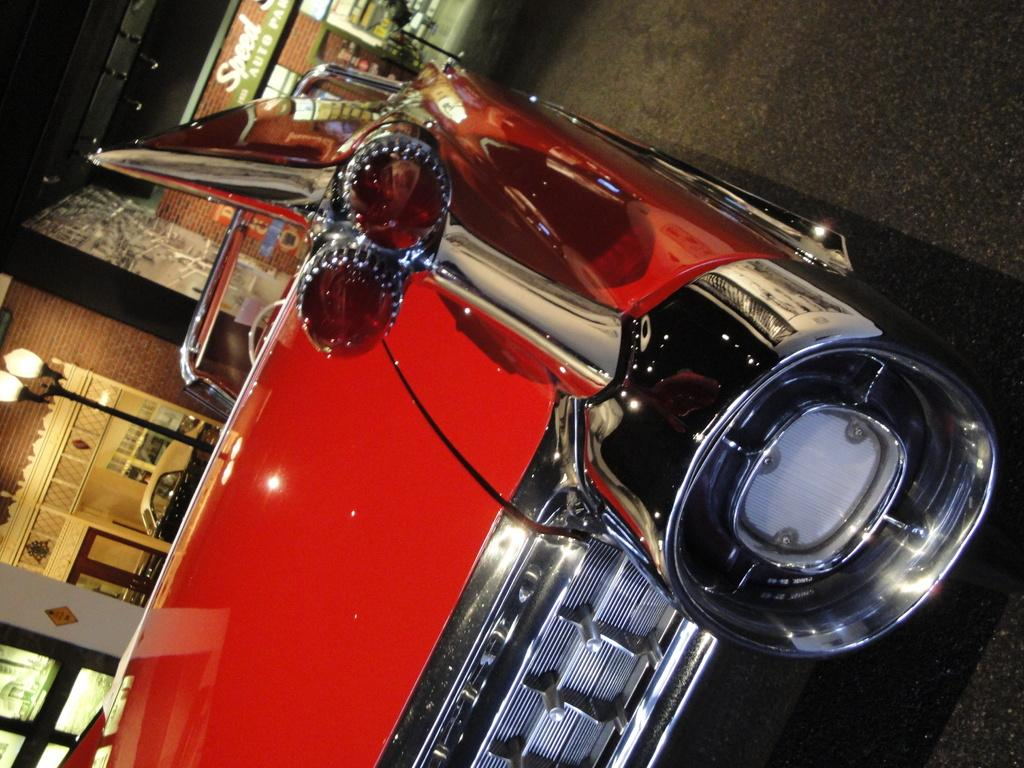What is the main subject of the image? There is a car in the image. Can you describe the car's appearance? The car is red. Where is the car located in the image? The car is on the road. What can be seen in the background of the image? There are buildings, lights, banners, a wall, glass, and a pole visible in the background of the image. What type of bait is being used to catch fish in the image? There is no fishing or bait present in the image; it features a red car on the road with various background elements. What do the banners in the background of the image say? The provided facts do not include any information about the content of the banners, so we cannot determine what they say. 